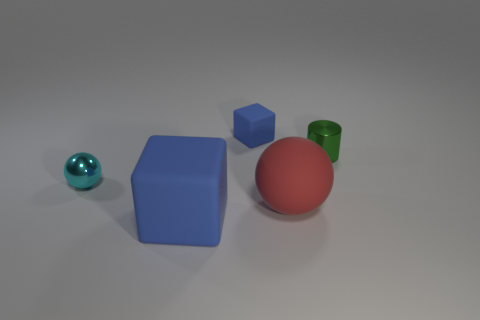There is a object that is both in front of the green object and right of the large cube; what is its size?
Your response must be concise. Large. How many cubes have the same material as the small green thing?
Your answer should be very brief. 0. What number of balls are large rubber objects or tiny shiny objects?
Your response must be concise. 2. What is the size of the shiny object that is right of the cube behind the rubber cube that is in front of the cyan object?
Your response must be concise. Small. The object that is both in front of the green shiny cylinder and behind the red sphere is what color?
Give a very brief answer. Cyan. Do the cyan thing and the blue rubber block that is in front of the small blue matte thing have the same size?
Your answer should be very brief. No. Is there anything else that has the same shape as the cyan metal thing?
Keep it short and to the point. Yes. What color is the other big thing that is the same shape as the cyan shiny object?
Give a very brief answer. Red. Do the cyan metal ball and the red rubber ball have the same size?
Your answer should be very brief. No. What number of other objects are there of the same size as the green shiny cylinder?
Your answer should be compact. 2. 